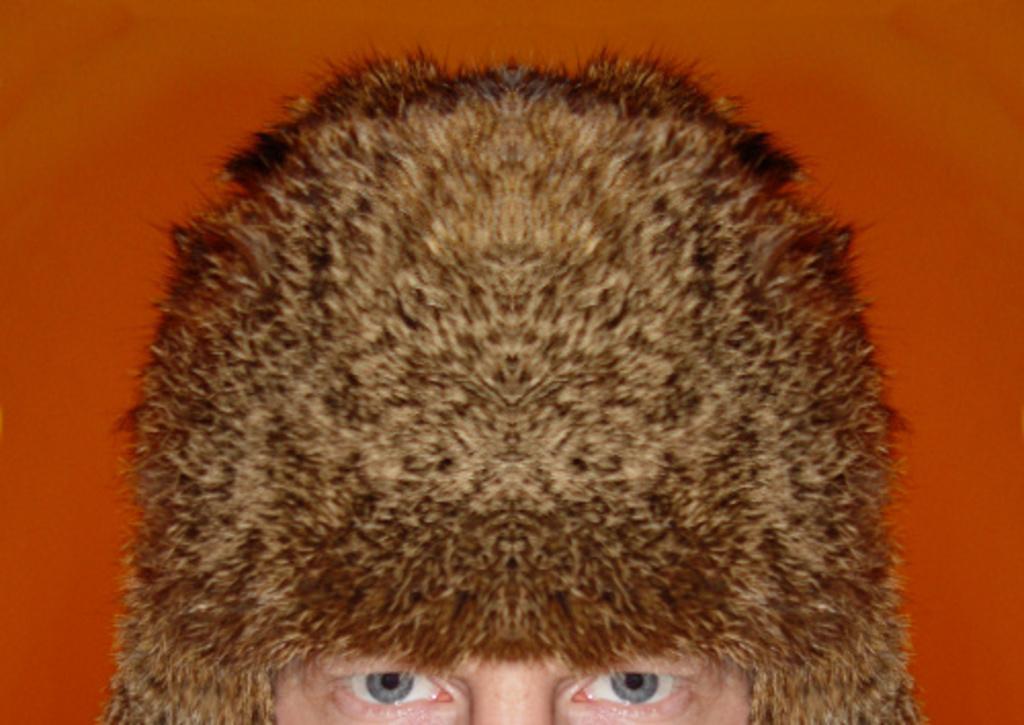In one or two sentences, can you explain what this image depicts? In the image I can see the person eye and the cap on the head. 